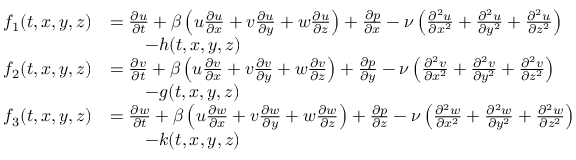Convert formula to latex. <formula><loc_0><loc_0><loc_500><loc_500>\begin{array} { r l } { f _ { 1 } ( t , x , y , z ) } & { = \frac { \partial u } { \partial t } + \beta \left ( u \frac { \partial u } { \partial x } + v \frac { \partial u } { \partial y } + w \frac { \partial u } { \partial z } \right ) + \frac { \partial p } { \partial x } - \nu \left ( \frac { \partial ^ { 2 } u } { \partial x ^ { 2 } } + \frac { \partial ^ { 2 } u } { \partial y ^ { 2 } } + \frac { \partial ^ { 2 } u } { \partial z ^ { 2 } } \right ) } \\ & { \quad - h ( t , x , y , z ) } \\ { f _ { 2 } ( t , x , y , z ) } & { = \frac { \partial v } { \partial t } + \beta \left ( u \frac { \partial v } { \partial x } + v \frac { \partial v } { \partial y } + w \frac { \partial v } { \partial z } \right ) + \frac { \partial p } { \partial y } - \nu \left ( \frac { \partial ^ { 2 } v } { \partial x ^ { 2 } } + \frac { \partial ^ { 2 } v } { \partial y ^ { 2 } } + \frac { \partial ^ { 2 } v } { \partial z ^ { 2 } } \right ) } \\ & { \quad - g ( t , x , y , z ) } \\ { f _ { 3 } ( t , x , y , z ) } & { = \frac { \partial w } { \partial t } + \beta \left ( u \frac { \partial w } { \partial x } + v \frac { \partial w } { \partial y } + w \frac { \partial w } { \partial z } \right ) + \frac { \partial p } { \partial z } - \nu \left ( \frac { \partial ^ { 2 } w } { \partial x ^ { 2 } } + \frac { \partial ^ { 2 } w } { \partial y ^ { 2 } } + \frac { \partial ^ { 2 } w } { \partial z ^ { 2 } } \right ) } \\ & { \quad - k ( t , x , y , z ) } \end{array}</formula> 